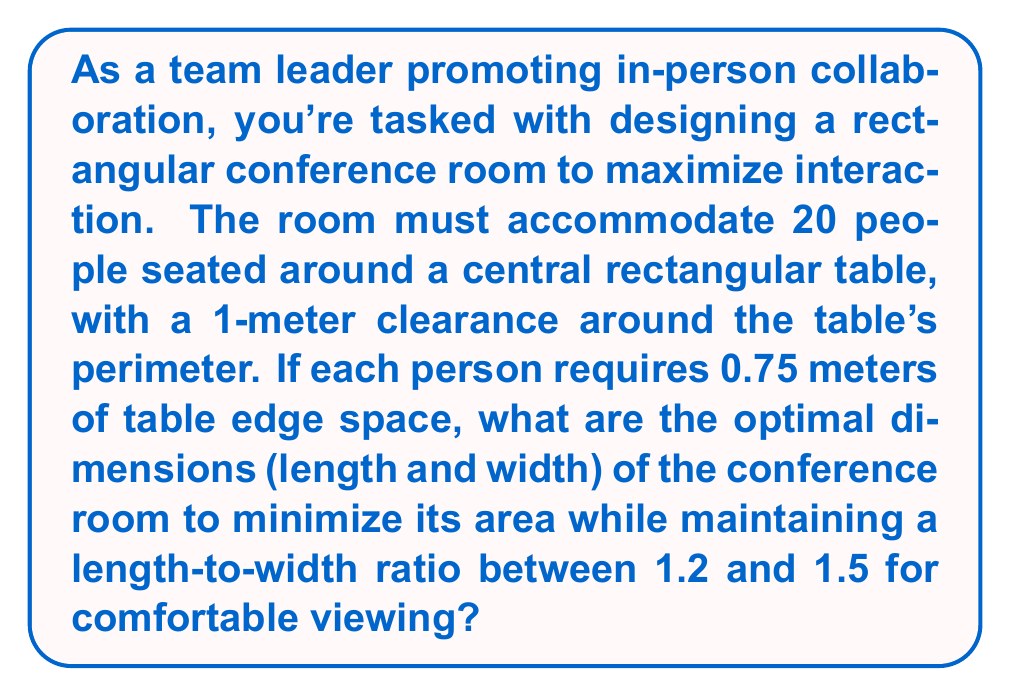Give your solution to this math problem. Let's approach this step-by-step:

1) Let the table's length be $l$ and width be $w$.

2) For 20 people, the table's perimeter must be:
   $$ 20 \times 0.75 = 15 \text{ meters} $$

3) The perimeter of a rectangle is given by $2l + 2w = 15$, so:
   $$ l + w = 7.5 $$

4) The room dimensions will be $(l+2)$ by $(w+2)$ to account for the 1-meter clearance.

5) The room's area $A$ is given by:
   $$ A = (l+2)(w+2) = lw + 2l + 2w + 4 $$

6) Substituting $w = 7.5 - l$ from step 3:
   $$ A = l(7.5-l) + 2l + 2(7.5-l) + 4 $$
   $$ A = 7.5l - l^2 + 2l + 15 - 2l + 4 $$
   $$ A = -l^2 + 7.5l + 19 $$

7) To find the minimum area, we differentiate and set to zero:
   $$ \frac{dA}{dl} = -2l + 7.5 = 0 $$
   $$ l = 3.75 $$

8) This gives $w = 7.5 - 3.75 = 3.75$

9) The room dimensions would be $5.75 \times 5.75$, but this doesn't meet our ratio requirement.

10) Let's check the endpoints of our ratio range:
    For 1.2 ratio: $l = 1.2w$, $l + w = 7.5$
    Solving: $w = 3.41$, $l = 4.09$
    Room: $6.09 \times 5.41$, Area = 32.95 m²

    For 1.5 ratio: $l = 1.5w$, $l + w = 7.5$
    Solving: $w = 3$, $l = 4.5$
    Room: $6.5 \times 5$, Area = 32.5 m²

11) The 1.5 ratio gives the smaller area while meeting all requirements.

[asy]
size(200);
draw((0,0)--(6.5,0)--(6.5,5)--(0,5)--cycle);
draw((1,1)--(5.5,1)--(5.5,4)--(1,4)--cycle);
label("6.5m", (3.25,0), S);
label("5m", (0,2.5), W);
label("4.5m", (3.25,1), N);
label("3m", (1,2.5), E);
[/asy]
Answer: The optimal dimensions for the conference room are 6.5 meters long by 5 meters wide, with a total area of 32.5 square meters. 